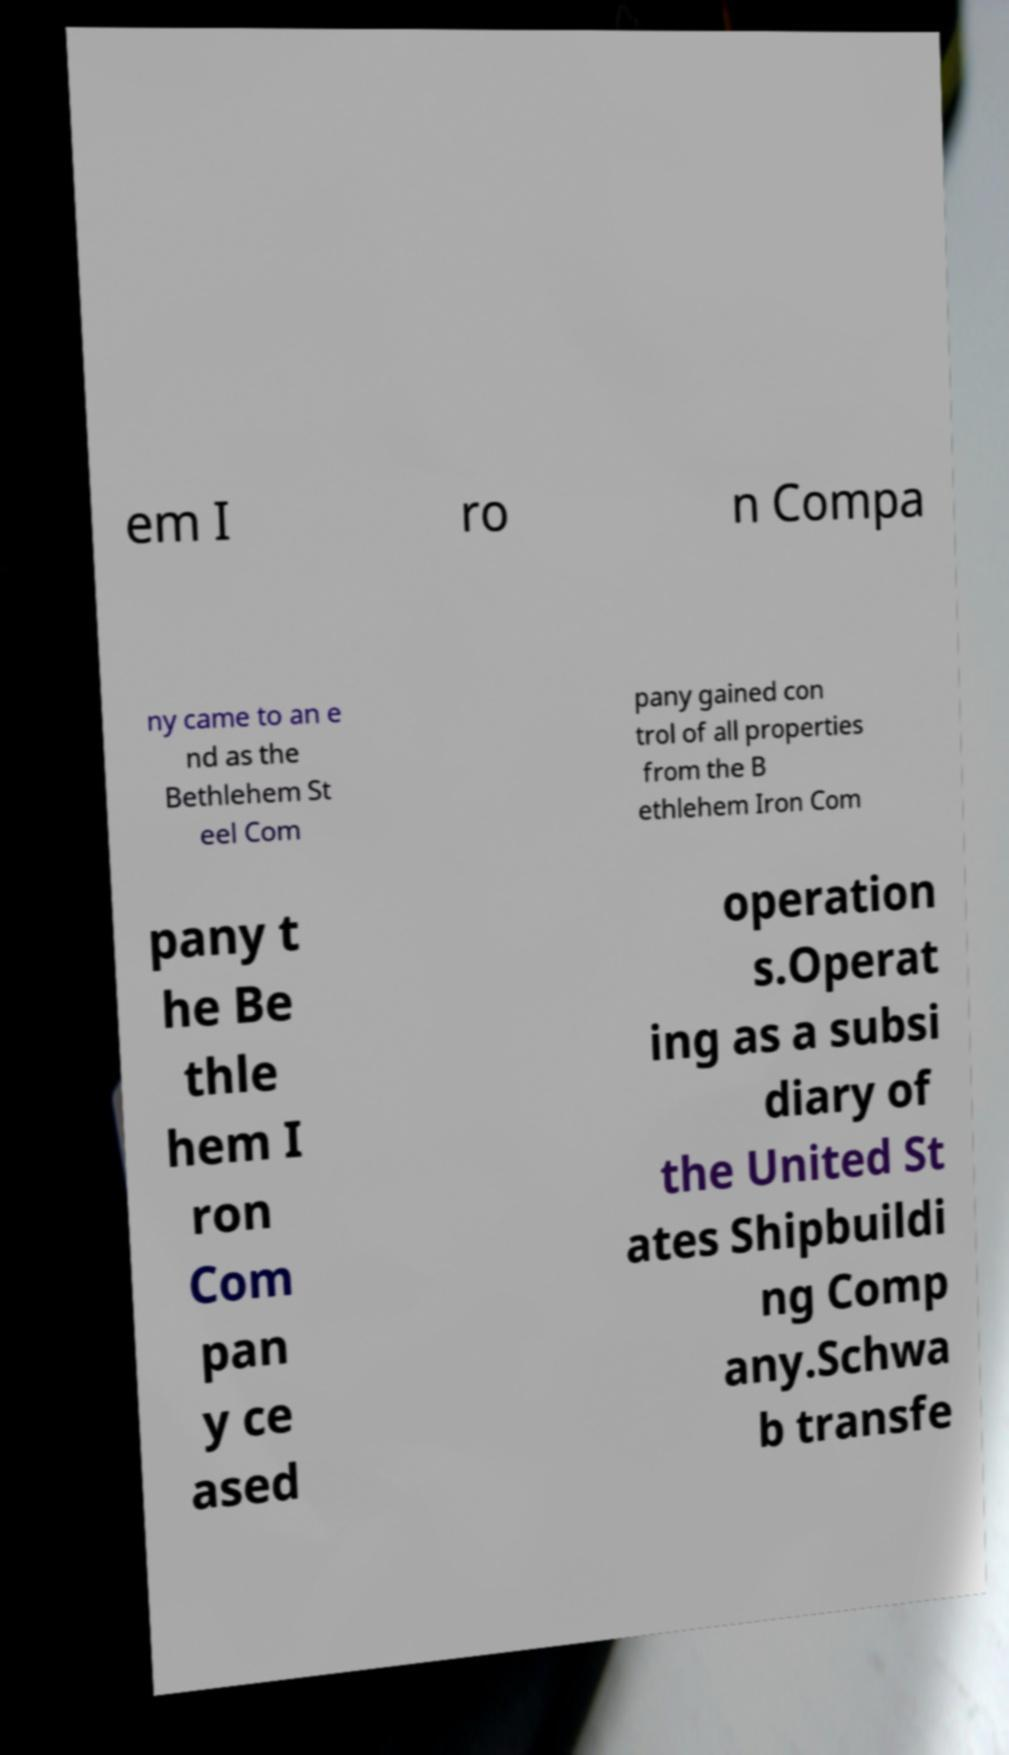Can you accurately transcribe the text from the provided image for me? em I ro n Compa ny came to an e nd as the Bethlehem St eel Com pany gained con trol of all properties from the B ethlehem Iron Com pany t he Be thle hem I ron Com pan y ce ased operation s.Operat ing as a subsi diary of the United St ates Shipbuildi ng Comp any.Schwa b transfe 